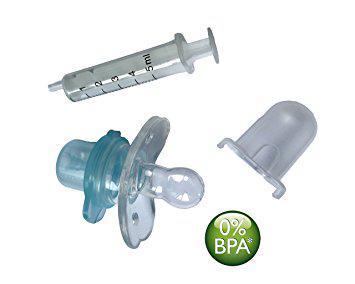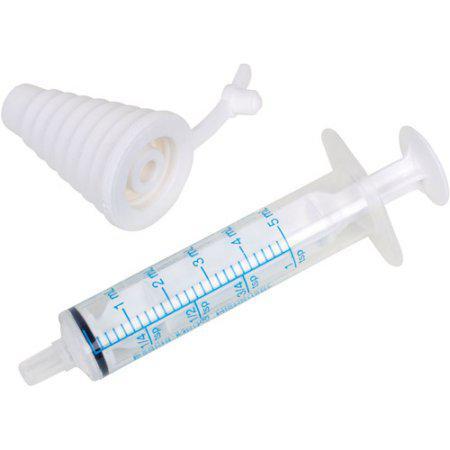The first image is the image on the left, the second image is the image on the right. Analyze the images presented: Is the assertion "The left image has a syringe with a nozzle, the right image has at least three syringes, and no image has a pacifier." valid? Answer yes or no. No. The first image is the image on the left, the second image is the image on the right. Given the left and right images, does the statement "At least one image includes an item resembling a pacifier next to a syringe." hold true? Answer yes or no. Yes. 